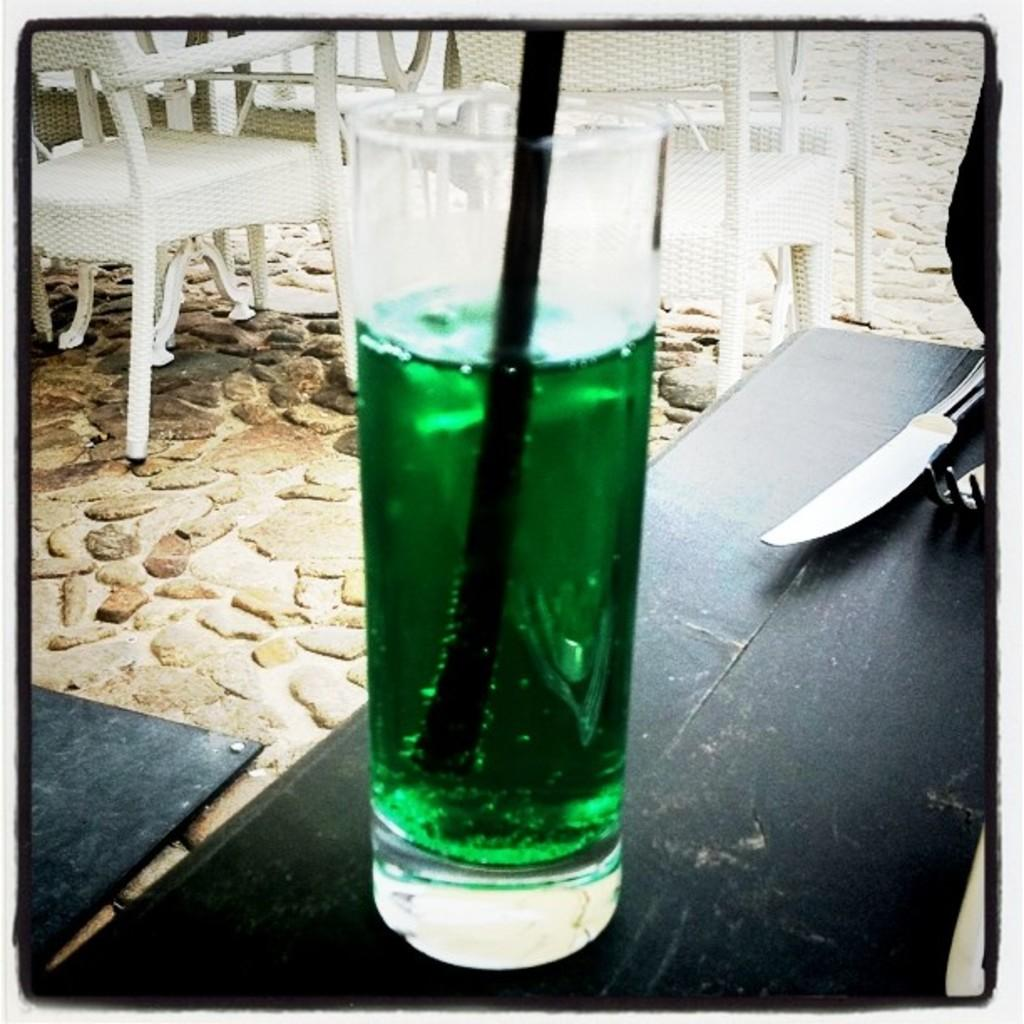What piece of furniture is in the image? There is a table in the image. What items are on the table? A knife, fork, and glass are present on the table. What type of seating is visible at the top of the image? There are chairs visible at the top of the image. What type of school is depicted in the image? There is no school present in the image; it features a table with a knife, fork, and glass, along with chairs visible at the top. 